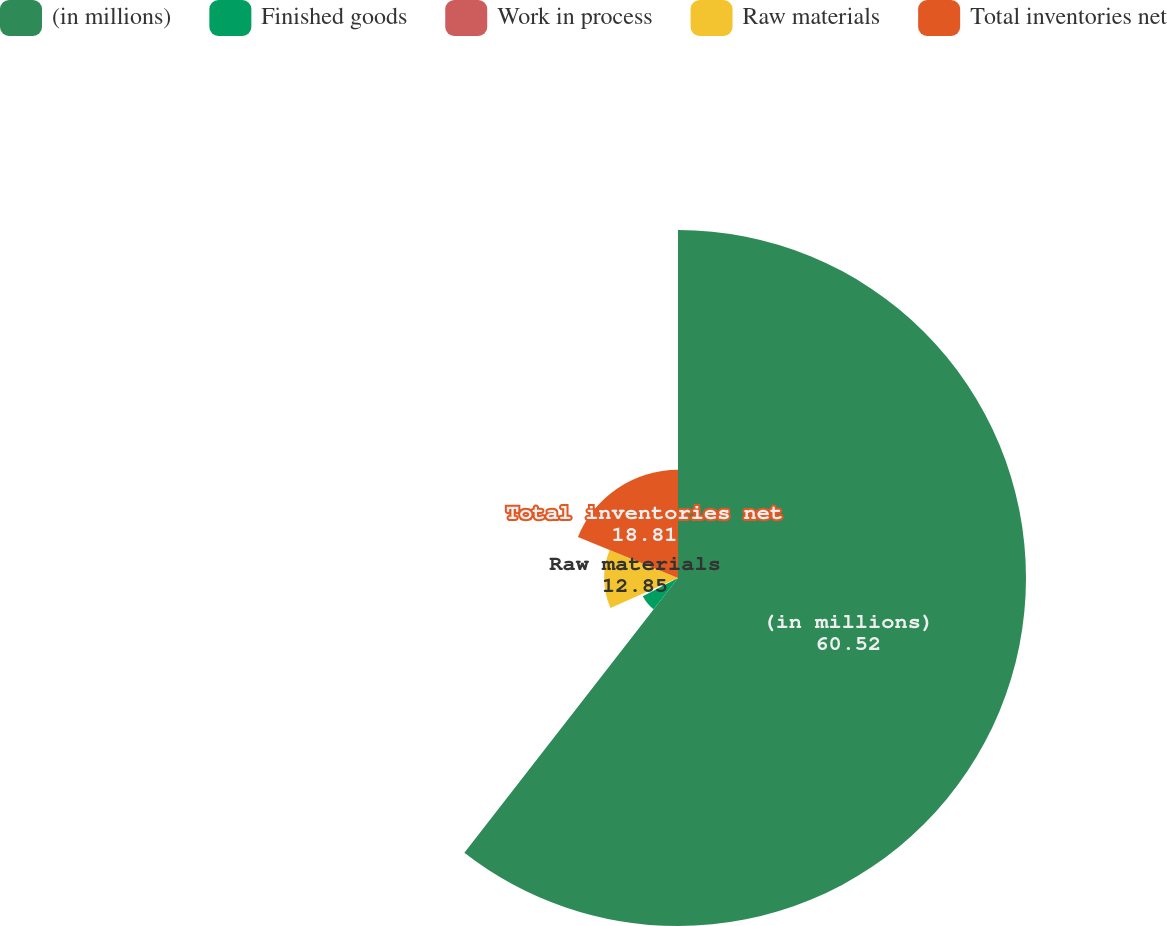<chart> <loc_0><loc_0><loc_500><loc_500><pie_chart><fcel>(in millions)<fcel>Finished goods<fcel>Work in process<fcel>Raw materials<fcel>Total inventories net<nl><fcel>60.52%<fcel>6.89%<fcel>0.93%<fcel>12.85%<fcel>18.81%<nl></chart> 